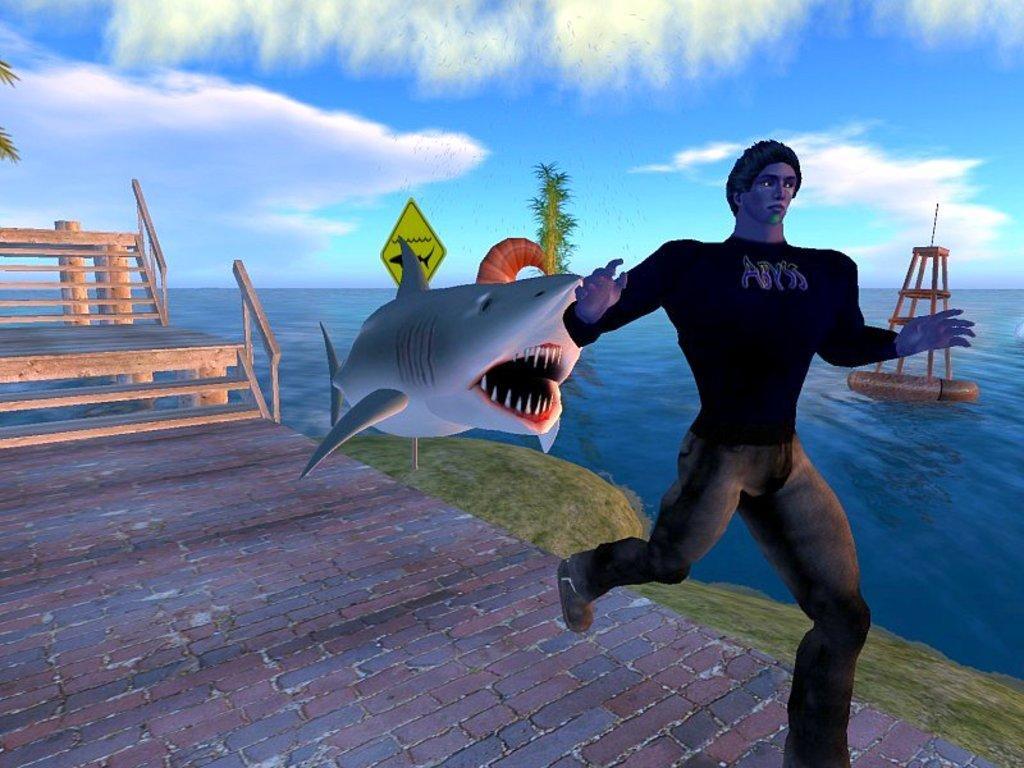Can you describe this image briefly? This image is an animated image. At the top of the image there is the sky with clouds and there is a floor. On the left side of the image there are a few stairs. There is a railing. In the middle of the image there is a shark about to bite a person. A man is running on the floor. In the background there is the sea. There is a tree and there is a signboard. 